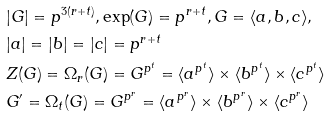<formula> <loc_0><loc_0><loc_500><loc_500>& | G | = p ^ { 3 ( r + t ) } , \text {exp} ( G ) = p ^ { r + t } , G = \langle a , b , c \rangle , \\ & | a | = | b | = | c | = p ^ { r + t } \\ & Z ( G ) = \Omega _ { r } ( G ) = G ^ { p ^ { t } } = \langle a ^ { p ^ { t } } \rangle \times \langle b ^ { p ^ { t } } \rangle \times \langle c ^ { p ^ { t } } \rangle \\ & G ^ { \prime } = \Omega _ { t } ( G ) = G ^ { p ^ { r } } = \langle a ^ { p ^ { r } } \rangle \times \langle b ^ { p ^ { r } } \rangle \times \langle c ^ { p ^ { r } } \rangle</formula> 